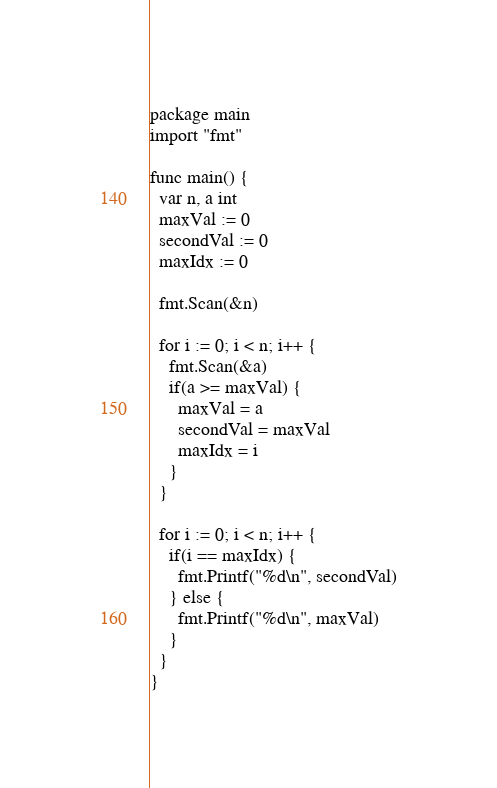<code> <loc_0><loc_0><loc_500><loc_500><_Go_>package main
import "fmt"
 
func main() {
  var n, a int
  maxVal := 0
  secondVal := 0
  maxIdx := 0
  
  fmt.Scan(&n)
  
  for i := 0; i < n; i++ {
    fmt.Scan(&a)
    if(a >= maxVal) {
      maxVal = a
      secondVal = maxVal
      maxIdx = i
    }
  }
  
  for i := 0; i < n; i++ {
    if(i == maxIdx) {
      fmt.Printf("%d\n", secondVal)
    } else {
      fmt.Printf("%d\n", maxVal)
    }
  }
}</code> 